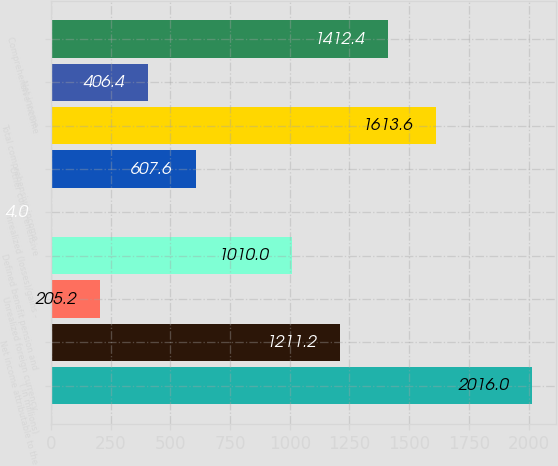Convert chart. <chart><loc_0><loc_0><loc_500><loc_500><bar_chart><fcel>( in millions)<fcel>Net income attributable to the<fcel>Unrealized foreign currency<fcel>Defined benefit pension and<fcel>Unrealized (losses)/gains -<fcel>Other comprehensive<fcel>Total comprehensive income<fcel>Net income<fcel>Comprehensive income<nl><fcel>2016<fcel>1211.2<fcel>205.2<fcel>1010<fcel>4<fcel>607.6<fcel>1613.6<fcel>406.4<fcel>1412.4<nl></chart> 